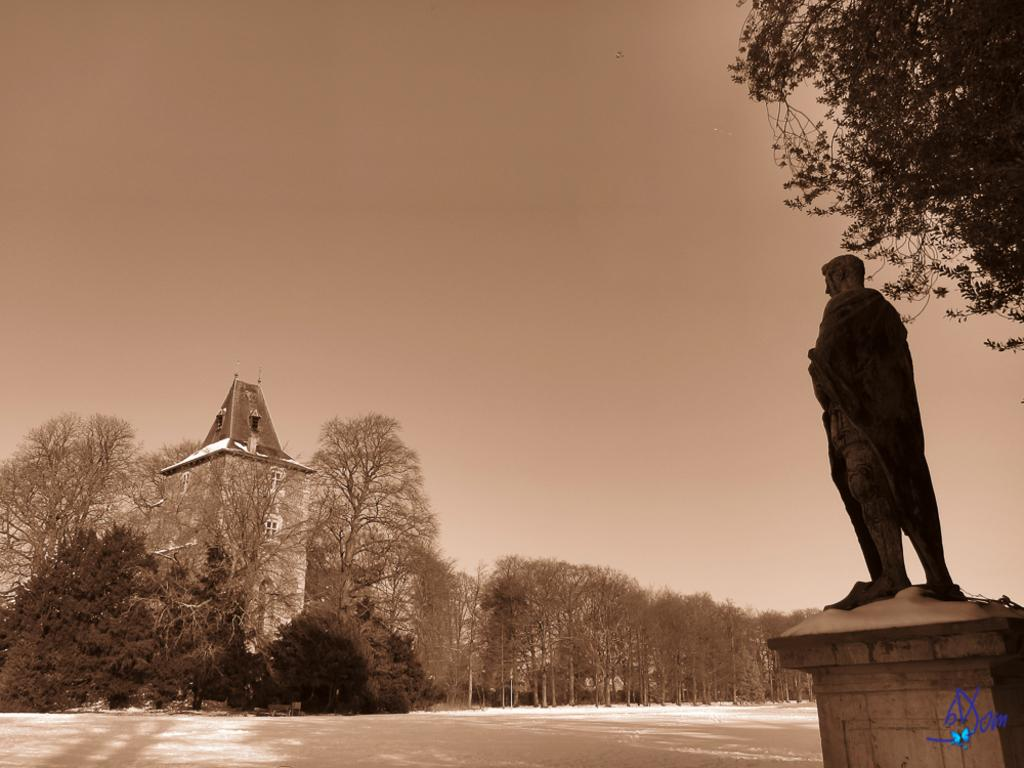What type of structure is present in the image? There is a building in the image. What other object can be seen in the image? There is a statue in the image. What type of vegetation is visible in the image? There are plants and trees in the image. What part of the natural environment is visible in the image? The ground and the sky are visible in the image. Is there any text present in the image? Yes, there is some text in the bottom right corner of the image. What type of cabbage is your sister holding in the image? There is no sister or cabbage present in the image. Who is the owner of the building in the image? The image does not provide information about the ownership of the building. 